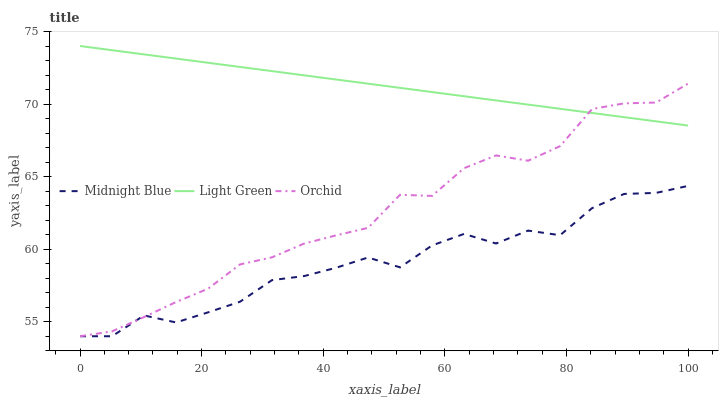Does Orchid have the minimum area under the curve?
Answer yes or no. No. Does Orchid have the maximum area under the curve?
Answer yes or no. No. Is Orchid the smoothest?
Answer yes or no. No. Is Orchid the roughest?
Answer yes or no. No. Does Light Green have the lowest value?
Answer yes or no. No. Does Orchid have the highest value?
Answer yes or no. No. Is Midnight Blue less than Light Green?
Answer yes or no. Yes. Is Light Green greater than Midnight Blue?
Answer yes or no. Yes. Does Midnight Blue intersect Light Green?
Answer yes or no. No. 